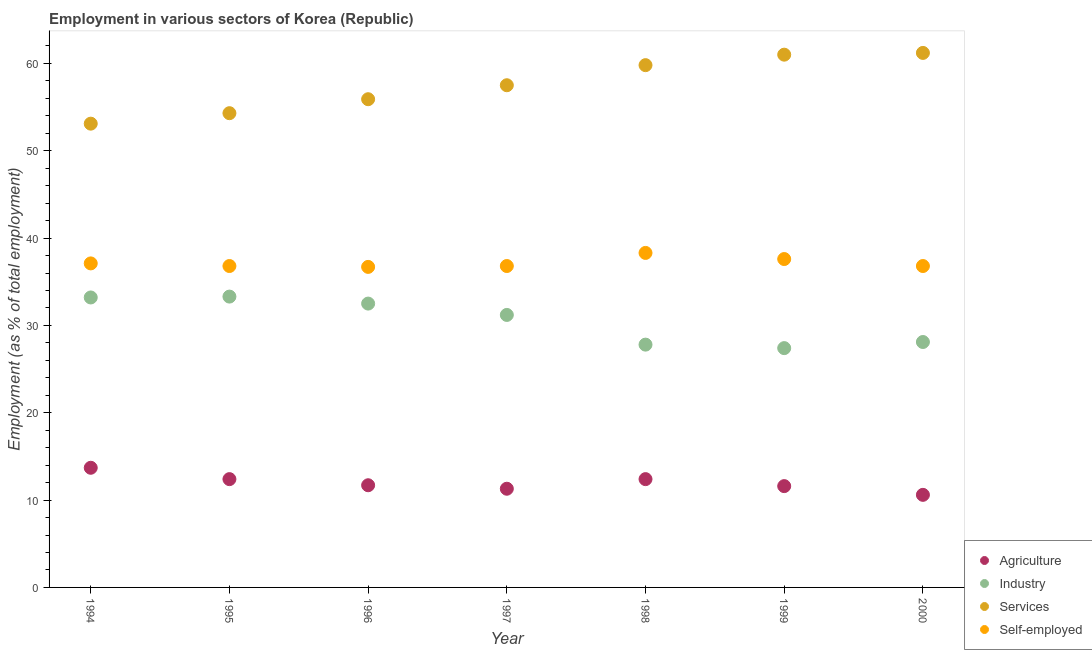How many different coloured dotlines are there?
Keep it short and to the point. 4. What is the percentage of workers in services in 1997?
Your answer should be compact. 57.5. Across all years, what is the maximum percentage of workers in services?
Your answer should be compact. 61.2. Across all years, what is the minimum percentage of workers in services?
Provide a short and direct response. 53.1. In which year was the percentage of self employed workers minimum?
Your answer should be compact. 1996. What is the total percentage of workers in agriculture in the graph?
Your response must be concise. 83.7. What is the difference between the percentage of self employed workers in 1994 and that in 1997?
Keep it short and to the point. 0.3. What is the difference between the percentage of workers in agriculture in 1998 and the percentage of workers in services in 1995?
Offer a very short reply. -41.9. What is the average percentage of workers in industry per year?
Offer a very short reply. 30.5. In the year 1996, what is the difference between the percentage of self employed workers and percentage of workers in services?
Your answer should be very brief. -19.2. What is the ratio of the percentage of self employed workers in 1999 to that in 2000?
Keep it short and to the point. 1.02. What is the difference between the highest and the second highest percentage of self employed workers?
Your answer should be very brief. 0.7. What is the difference between the highest and the lowest percentage of workers in agriculture?
Keep it short and to the point. 3.1. In how many years, is the percentage of self employed workers greater than the average percentage of self employed workers taken over all years?
Your answer should be compact. 2. Is the sum of the percentage of self employed workers in 1994 and 1997 greater than the maximum percentage of workers in industry across all years?
Your answer should be very brief. Yes. Does the percentage of workers in services monotonically increase over the years?
Provide a succinct answer. Yes. Is the percentage of workers in services strictly less than the percentage of workers in industry over the years?
Offer a very short reply. No. How many years are there in the graph?
Make the answer very short. 7. What is the difference between two consecutive major ticks on the Y-axis?
Offer a very short reply. 10. Are the values on the major ticks of Y-axis written in scientific E-notation?
Your answer should be very brief. No. Does the graph contain any zero values?
Make the answer very short. No. What is the title of the graph?
Provide a short and direct response. Employment in various sectors of Korea (Republic). What is the label or title of the X-axis?
Your answer should be very brief. Year. What is the label or title of the Y-axis?
Offer a very short reply. Employment (as % of total employment). What is the Employment (as % of total employment) in Agriculture in 1994?
Ensure brevity in your answer.  13.7. What is the Employment (as % of total employment) in Industry in 1994?
Your answer should be very brief. 33.2. What is the Employment (as % of total employment) of Services in 1994?
Make the answer very short. 53.1. What is the Employment (as % of total employment) in Self-employed in 1994?
Provide a short and direct response. 37.1. What is the Employment (as % of total employment) of Agriculture in 1995?
Your response must be concise. 12.4. What is the Employment (as % of total employment) in Industry in 1995?
Your answer should be compact. 33.3. What is the Employment (as % of total employment) of Services in 1995?
Your answer should be compact. 54.3. What is the Employment (as % of total employment) of Self-employed in 1995?
Provide a succinct answer. 36.8. What is the Employment (as % of total employment) of Agriculture in 1996?
Give a very brief answer. 11.7. What is the Employment (as % of total employment) in Industry in 1996?
Your answer should be compact. 32.5. What is the Employment (as % of total employment) of Services in 1996?
Make the answer very short. 55.9. What is the Employment (as % of total employment) in Self-employed in 1996?
Make the answer very short. 36.7. What is the Employment (as % of total employment) of Agriculture in 1997?
Your answer should be very brief. 11.3. What is the Employment (as % of total employment) in Industry in 1997?
Your response must be concise. 31.2. What is the Employment (as % of total employment) of Services in 1997?
Ensure brevity in your answer.  57.5. What is the Employment (as % of total employment) of Self-employed in 1997?
Give a very brief answer. 36.8. What is the Employment (as % of total employment) of Agriculture in 1998?
Your answer should be compact. 12.4. What is the Employment (as % of total employment) of Industry in 1998?
Your answer should be compact. 27.8. What is the Employment (as % of total employment) of Services in 1998?
Make the answer very short. 59.8. What is the Employment (as % of total employment) of Self-employed in 1998?
Provide a succinct answer. 38.3. What is the Employment (as % of total employment) of Agriculture in 1999?
Ensure brevity in your answer.  11.6. What is the Employment (as % of total employment) of Industry in 1999?
Your answer should be very brief. 27.4. What is the Employment (as % of total employment) of Self-employed in 1999?
Make the answer very short. 37.6. What is the Employment (as % of total employment) of Agriculture in 2000?
Give a very brief answer. 10.6. What is the Employment (as % of total employment) of Industry in 2000?
Your answer should be very brief. 28.1. What is the Employment (as % of total employment) in Services in 2000?
Provide a succinct answer. 61.2. What is the Employment (as % of total employment) in Self-employed in 2000?
Give a very brief answer. 36.8. Across all years, what is the maximum Employment (as % of total employment) of Agriculture?
Offer a very short reply. 13.7. Across all years, what is the maximum Employment (as % of total employment) in Industry?
Give a very brief answer. 33.3. Across all years, what is the maximum Employment (as % of total employment) of Services?
Offer a terse response. 61.2. Across all years, what is the maximum Employment (as % of total employment) of Self-employed?
Make the answer very short. 38.3. Across all years, what is the minimum Employment (as % of total employment) in Agriculture?
Your response must be concise. 10.6. Across all years, what is the minimum Employment (as % of total employment) in Industry?
Provide a succinct answer. 27.4. Across all years, what is the minimum Employment (as % of total employment) in Services?
Provide a succinct answer. 53.1. Across all years, what is the minimum Employment (as % of total employment) in Self-employed?
Offer a very short reply. 36.7. What is the total Employment (as % of total employment) in Agriculture in the graph?
Your response must be concise. 83.7. What is the total Employment (as % of total employment) in Industry in the graph?
Provide a short and direct response. 213.5. What is the total Employment (as % of total employment) in Services in the graph?
Offer a terse response. 402.8. What is the total Employment (as % of total employment) of Self-employed in the graph?
Your response must be concise. 260.1. What is the difference between the Employment (as % of total employment) in Self-employed in 1994 and that in 1995?
Your response must be concise. 0.3. What is the difference between the Employment (as % of total employment) of Agriculture in 1994 and that in 1996?
Your answer should be compact. 2. What is the difference between the Employment (as % of total employment) in Services in 1994 and that in 1996?
Offer a very short reply. -2.8. What is the difference between the Employment (as % of total employment) in Self-employed in 1994 and that in 1996?
Keep it short and to the point. 0.4. What is the difference between the Employment (as % of total employment) of Services in 1994 and that in 1997?
Your answer should be very brief. -4.4. What is the difference between the Employment (as % of total employment) of Self-employed in 1994 and that in 1997?
Your answer should be very brief. 0.3. What is the difference between the Employment (as % of total employment) in Agriculture in 1994 and that in 1998?
Give a very brief answer. 1.3. What is the difference between the Employment (as % of total employment) of Industry in 1994 and that in 1998?
Keep it short and to the point. 5.4. What is the difference between the Employment (as % of total employment) in Self-employed in 1994 and that in 1998?
Give a very brief answer. -1.2. What is the difference between the Employment (as % of total employment) in Agriculture in 1994 and that in 1999?
Ensure brevity in your answer.  2.1. What is the difference between the Employment (as % of total employment) in Agriculture in 1994 and that in 2000?
Offer a terse response. 3.1. What is the difference between the Employment (as % of total employment) of Self-employed in 1994 and that in 2000?
Ensure brevity in your answer.  0.3. What is the difference between the Employment (as % of total employment) in Agriculture in 1995 and that in 1996?
Ensure brevity in your answer.  0.7. What is the difference between the Employment (as % of total employment) of Industry in 1995 and that in 1996?
Your response must be concise. 0.8. What is the difference between the Employment (as % of total employment) in Self-employed in 1995 and that in 1996?
Ensure brevity in your answer.  0.1. What is the difference between the Employment (as % of total employment) of Industry in 1995 and that in 1997?
Give a very brief answer. 2.1. What is the difference between the Employment (as % of total employment) in Self-employed in 1995 and that in 1997?
Make the answer very short. 0. What is the difference between the Employment (as % of total employment) of Industry in 1995 and that in 1998?
Your response must be concise. 5.5. What is the difference between the Employment (as % of total employment) of Services in 1995 and that in 1999?
Offer a very short reply. -6.7. What is the difference between the Employment (as % of total employment) of Self-employed in 1995 and that in 2000?
Ensure brevity in your answer.  0. What is the difference between the Employment (as % of total employment) of Agriculture in 1996 and that in 1997?
Ensure brevity in your answer.  0.4. What is the difference between the Employment (as % of total employment) of Self-employed in 1996 and that in 1997?
Your response must be concise. -0.1. What is the difference between the Employment (as % of total employment) of Agriculture in 1996 and that in 1998?
Your answer should be very brief. -0.7. What is the difference between the Employment (as % of total employment) in Services in 1996 and that in 1998?
Offer a terse response. -3.9. What is the difference between the Employment (as % of total employment) in Agriculture in 1996 and that in 1999?
Your answer should be very brief. 0.1. What is the difference between the Employment (as % of total employment) of Services in 1996 and that in 1999?
Your answer should be compact. -5.1. What is the difference between the Employment (as % of total employment) of Self-employed in 1996 and that in 1999?
Keep it short and to the point. -0.9. What is the difference between the Employment (as % of total employment) of Services in 1996 and that in 2000?
Offer a very short reply. -5.3. What is the difference between the Employment (as % of total employment) of Agriculture in 1997 and that in 1998?
Make the answer very short. -1.1. What is the difference between the Employment (as % of total employment) in Industry in 1997 and that in 1998?
Your answer should be very brief. 3.4. What is the difference between the Employment (as % of total employment) of Self-employed in 1997 and that in 1998?
Your response must be concise. -1.5. What is the difference between the Employment (as % of total employment) of Agriculture in 1997 and that in 1999?
Your answer should be compact. -0.3. What is the difference between the Employment (as % of total employment) in Industry in 1997 and that in 1999?
Offer a very short reply. 3.8. What is the difference between the Employment (as % of total employment) of Self-employed in 1997 and that in 1999?
Offer a terse response. -0.8. What is the difference between the Employment (as % of total employment) in Services in 1997 and that in 2000?
Offer a terse response. -3.7. What is the difference between the Employment (as % of total employment) of Self-employed in 1997 and that in 2000?
Provide a short and direct response. 0. What is the difference between the Employment (as % of total employment) in Agriculture in 1998 and that in 1999?
Keep it short and to the point. 0.8. What is the difference between the Employment (as % of total employment) of Industry in 1998 and that in 1999?
Keep it short and to the point. 0.4. What is the difference between the Employment (as % of total employment) of Self-employed in 1998 and that in 1999?
Your response must be concise. 0.7. What is the difference between the Employment (as % of total employment) of Agriculture in 1998 and that in 2000?
Offer a terse response. 1.8. What is the difference between the Employment (as % of total employment) in Industry in 1998 and that in 2000?
Ensure brevity in your answer.  -0.3. What is the difference between the Employment (as % of total employment) in Services in 1998 and that in 2000?
Your response must be concise. -1.4. What is the difference between the Employment (as % of total employment) of Self-employed in 1998 and that in 2000?
Provide a short and direct response. 1.5. What is the difference between the Employment (as % of total employment) in Agriculture in 1999 and that in 2000?
Provide a short and direct response. 1. What is the difference between the Employment (as % of total employment) in Industry in 1999 and that in 2000?
Your answer should be very brief. -0.7. What is the difference between the Employment (as % of total employment) in Services in 1999 and that in 2000?
Make the answer very short. -0.2. What is the difference between the Employment (as % of total employment) in Self-employed in 1999 and that in 2000?
Provide a succinct answer. 0.8. What is the difference between the Employment (as % of total employment) of Agriculture in 1994 and the Employment (as % of total employment) of Industry in 1995?
Your response must be concise. -19.6. What is the difference between the Employment (as % of total employment) of Agriculture in 1994 and the Employment (as % of total employment) of Services in 1995?
Give a very brief answer. -40.6. What is the difference between the Employment (as % of total employment) in Agriculture in 1994 and the Employment (as % of total employment) in Self-employed in 1995?
Offer a terse response. -23.1. What is the difference between the Employment (as % of total employment) in Industry in 1994 and the Employment (as % of total employment) in Services in 1995?
Make the answer very short. -21.1. What is the difference between the Employment (as % of total employment) of Services in 1994 and the Employment (as % of total employment) of Self-employed in 1995?
Provide a short and direct response. 16.3. What is the difference between the Employment (as % of total employment) in Agriculture in 1994 and the Employment (as % of total employment) in Industry in 1996?
Give a very brief answer. -18.8. What is the difference between the Employment (as % of total employment) in Agriculture in 1994 and the Employment (as % of total employment) in Services in 1996?
Keep it short and to the point. -42.2. What is the difference between the Employment (as % of total employment) in Industry in 1994 and the Employment (as % of total employment) in Services in 1996?
Your answer should be very brief. -22.7. What is the difference between the Employment (as % of total employment) in Agriculture in 1994 and the Employment (as % of total employment) in Industry in 1997?
Your response must be concise. -17.5. What is the difference between the Employment (as % of total employment) in Agriculture in 1994 and the Employment (as % of total employment) in Services in 1997?
Offer a very short reply. -43.8. What is the difference between the Employment (as % of total employment) of Agriculture in 1994 and the Employment (as % of total employment) of Self-employed in 1997?
Provide a short and direct response. -23.1. What is the difference between the Employment (as % of total employment) in Industry in 1994 and the Employment (as % of total employment) in Services in 1997?
Ensure brevity in your answer.  -24.3. What is the difference between the Employment (as % of total employment) in Industry in 1994 and the Employment (as % of total employment) in Self-employed in 1997?
Your answer should be compact. -3.6. What is the difference between the Employment (as % of total employment) in Services in 1994 and the Employment (as % of total employment) in Self-employed in 1997?
Offer a very short reply. 16.3. What is the difference between the Employment (as % of total employment) in Agriculture in 1994 and the Employment (as % of total employment) in Industry in 1998?
Keep it short and to the point. -14.1. What is the difference between the Employment (as % of total employment) in Agriculture in 1994 and the Employment (as % of total employment) in Services in 1998?
Ensure brevity in your answer.  -46.1. What is the difference between the Employment (as % of total employment) of Agriculture in 1994 and the Employment (as % of total employment) of Self-employed in 1998?
Your answer should be very brief. -24.6. What is the difference between the Employment (as % of total employment) in Industry in 1994 and the Employment (as % of total employment) in Services in 1998?
Provide a short and direct response. -26.6. What is the difference between the Employment (as % of total employment) of Agriculture in 1994 and the Employment (as % of total employment) of Industry in 1999?
Give a very brief answer. -13.7. What is the difference between the Employment (as % of total employment) of Agriculture in 1994 and the Employment (as % of total employment) of Services in 1999?
Provide a short and direct response. -47.3. What is the difference between the Employment (as % of total employment) in Agriculture in 1994 and the Employment (as % of total employment) in Self-employed in 1999?
Your answer should be compact. -23.9. What is the difference between the Employment (as % of total employment) of Industry in 1994 and the Employment (as % of total employment) of Services in 1999?
Give a very brief answer. -27.8. What is the difference between the Employment (as % of total employment) of Services in 1994 and the Employment (as % of total employment) of Self-employed in 1999?
Provide a short and direct response. 15.5. What is the difference between the Employment (as % of total employment) of Agriculture in 1994 and the Employment (as % of total employment) of Industry in 2000?
Your answer should be very brief. -14.4. What is the difference between the Employment (as % of total employment) in Agriculture in 1994 and the Employment (as % of total employment) in Services in 2000?
Keep it short and to the point. -47.5. What is the difference between the Employment (as % of total employment) in Agriculture in 1994 and the Employment (as % of total employment) in Self-employed in 2000?
Keep it short and to the point. -23.1. What is the difference between the Employment (as % of total employment) of Services in 1994 and the Employment (as % of total employment) of Self-employed in 2000?
Your response must be concise. 16.3. What is the difference between the Employment (as % of total employment) in Agriculture in 1995 and the Employment (as % of total employment) in Industry in 1996?
Ensure brevity in your answer.  -20.1. What is the difference between the Employment (as % of total employment) in Agriculture in 1995 and the Employment (as % of total employment) in Services in 1996?
Your response must be concise. -43.5. What is the difference between the Employment (as % of total employment) of Agriculture in 1995 and the Employment (as % of total employment) of Self-employed in 1996?
Provide a succinct answer. -24.3. What is the difference between the Employment (as % of total employment) of Industry in 1995 and the Employment (as % of total employment) of Services in 1996?
Provide a succinct answer. -22.6. What is the difference between the Employment (as % of total employment) of Industry in 1995 and the Employment (as % of total employment) of Self-employed in 1996?
Keep it short and to the point. -3.4. What is the difference between the Employment (as % of total employment) in Services in 1995 and the Employment (as % of total employment) in Self-employed in 1996?
Your response must be concise. 17.6. What is the difference between the Employment (as % of total employment) in Agriculture in 1995 and the Employment (as % of total employment) in Industry in 1997?
Provide a short and direct response. -18.8. What is the difference between the Employment (as % of total employment) in Agriculture in 1995 and the Employment (as % of total employment) in Services in 1997?
Your answer should be very brief. -45.1. What is the difference between the Employment (as % of total employment) in Agriculture in 1995 and the Employment (as % of total employment) in Self-employed in 1997?
Keep it short and to the point. -24.4. What is the difference between the Employment (as % of total employment) in Industry in 1995 and the Employment (as % of total employment) in Services in 1997?
Provide a short and direct response. -24.2. What is the difference between the Employment (as % of total employment) in Industry in 1995 and the Employment (as % of total employment) in Self-employed in 1997?
Keep it short and to the point. -3.5. What is the difference between the Employment (as % of total employment) of Services in 1995 and the Employment (as % of total employment) of Self-employed in 1997?
Your answer should be very brief. 17.5. What is the difference between the Employment (as % of total employment) in Agriculture in 1995 and the Employment (as % of total employment) in Industry in 1998?
Your response must be concise. -15.4. What is the difference between the Employment (as % of total employment) in Agriculture in 1995 and the Employment (as % of total employment) in Services in 1998?
Offer a terse response. -47.4. What is the difference between the Employment (as % of total employment) in Agriculture in 1995 and the Employment (as % of total employment) in Self-employed in 1998?
Keep it short and to the point. -25.9. What is the difference between the Employment (as % of total employment) of Industry in 1995 and the Employment (as % of total employment) of Services in 1998?
Provide a short and direct response. -26.5. What is the difference between the Employment (as % of total employment) of Industry in 1995 and the Employment (as % of total employment) of Self-employed in 1998?
Ensure brevity in your answer.  -5. What is the difference between the Employment (as % of total employment) of Services in 1995 and the Employment (as % of total employment) of Self-employed in 1998?
Your response must be concise. 16. What is the difference between the Employment (as % of total employment) in Agriculture in 1995 and the Employment (as % of total employment) in Industry in 1999?
Give a very brief answer. -15. What is the difference between the Employment (as % of total employment) of Agriculture in 1995 and the Employment (as % of total employment) of Services in 1999?
Make the answer very short. -48.6. What is the difference between the Employment (as % of total employment) in Agriculture in 1995 and the Employment (as % of total employment) in Self-employed in 1999?
Ensure brevity in your answer.  -25.2. What is the difference between the Employment (as % of total employment) of Industry in 1995 and the Employment (as % of total employment) of Services in 1999?
Make the answer very short. -27.7. What is the difference between the Employment (as % of total employment) in Services in 1995 and the Employment (as % of total employment) in Self-employed in 1999?
Provide a succinct answer. 16.7. What is the difference between the Employment (as % of total employment) in Agriculture in 1995 and the Employment (as % of total employment) in Industry in 2000?
Provide a short and direct response. -15.7. What is the difference between the Employment (as % of total employment) in Agriculture in 1995 and the Employment (as % of total employment) in Services in 2000?
Your answer should be very brief. -48.8. What is the difference between the Employment (as % of total employment) in Agriculture in 1995 and the Employment (as % of total employment) in Self-employed in 2000?
Your answer should be compact. -24.4. What is the difference between the Employment (as % of total employment) of Industry in 1995 and the Employment (as % of total employment) of Services in 2000?
Give a very brief answer. -27.9. What is the difference between the Employment (as % of total employment) of Industry in 1995 and the Employment (as % of total employment) of Self-employed in 2000?
Your answer should be very brief. -3.5. What is the difference between the Employment (as % of total employment) in Services in 1995 and the Employment (as % of total employment) in Self-employed in 2000?
Keep it short and to the point. 17.5. What is the difference between the Employment (as % of total employment) in Agriculture in 1996 and the Employment (as % of total employment) in Industry in 1997?
Make the answer very short. -19.5. What is the difference between the Employment (as % of total employment) of Agriculture in 1996 and the Employment (as % of total employment) of Services in 1997?
Keep it short and to the point. -45.8. What is the difference between the Employment (as % of total employment) in Agriculture in 1996 and the Employment (as % of total employment) in Self-employed in 1997?
Offer a very short reply. -25.1. What is the difference between the Employment (as % of total employment) of Industry in 1996 and the Employment (as % of total employment) of Services in 1997?
Your answer should be very brief. -25. What is the difference between the Employment (as % of total employment) in Services in 1996 and the Employment (as % of total employment) in Self-employed in 1997?
Ensure brevity in your answer.  19.1. What is the difference between the Employment (as % of total employment) of Agriculture in 1996 and the Employment (as % of total employment) of Industry in 1998?
Ensure brevity in your answer.  -16.1. What is the difference between the Employment (as % of total employment) in Agriculture in 1996 and the Employment (as % of total employment) in Services in 1998?
Make the answer very short. -48.1. What is the difference between the Employment (as % of total employment) of Agriculture in 1996 and the Employment (as % of total employment) of Self-employed in 1998?
Provide a short and direct response. -26.6. What is the difference between the Employment (as % of total employment) of Industry in 1996 and the Employment (as % of total employment) of Services in 1998?
Keep it short and to the point. -27.3. What is the difference between the Employment (as % of total employment) of Services in 1996 and the Employment (as % of total employment) of Self-employed in 1998?
Make the answer very short. 17.6. What is the difference between the Employment (as % of total employment) in Agriculture in 1996 and the Employment (as % of total employment) in Industry in 1999?
Keep it short and to the point. -15.7. What is the difference between the Employment (as % of total employment) of Agriculture in 1996 and the Employment (as % of total employment) of Services in 1999?
Ensure brevity in your answer.  -49.3. What is the difference between the Employment (as % of total employment) of Agriculture in 1996 and the Employment (as % of total employment) of Self-employed in 1999?
Ensure brevity in your answer.  -25.9. What is the difference between the Employment (as % of total employment) of Industry in 1996 and the Employment (as % of total employment) of Services in 1999?
Your answer should be very brief. -28.5. What is the difference between the Employment (as % of total employment) of Industry in 1996 and the Employment (as % of total employment) of Self-employed in 1999?
Provide a succinct answer. -5.1. What is the difference between the Employment (as % of total employment) of Services in 1996 and the Employment (as % of total employment) of Self-employed in 1999?
Give a very brief answer. 18.3. What is the difference between the Employment (as % of total employment) in Agriculture in 1996 and the Employment (as % of total employment) in Industry in 2000?
Provide a short and direct response. -16.4. What is the difference between the Employment (as % of total employment) of Agriculture in 1996 and the Employment (as % of total employment) of Services in 2000?
Give a very brief answer. -49.5. What is the difference between the Employment (as % of total employment) of Agriculture in 1996 and the Employment (as % of total employment) of Self-employed in 2000?
Provide a succinct answer. -25.1. What is the difference between the Employment (as % of total employment) of Industry in 1996 and the Employment (as % of total employment) of Services in 2000?
Provide a succinct answer. -28.7. What is the difference between the Employment (as % of total employment) of Industry in 1996 and the Employment (as % of total employment) of Self-employed in 2000?
Give a very brief answer. -4.3. What is the difference between the Employment (as % of total employment) in Agriculture in 1997 and the Employment (as % of total employment) in Industry in 1998?
Make the answer very short. -16.5. What is the difference between the Employment (as % of total employment) of Agriculture in 1997 and the Employment (as % of total employment) of Services in 1998?
Ensure brevity in your answer.  -48.5. What is the difference between the Employment (as % of total employment) in Industry in 1997 and the Employment (as % of total employment) in Services in 1998?
Make the answer very short. -28.6. What is the difference between the Employment (as % of total employment) of Industry in 1997 and the Employment (as % of total employment) of Self-employed in 1998?
Keep it short and to the point. -7.1. What is the difference between the Employment (as % of total employment) of Services in 1997 and the Employment (as % of total employment) of Self-employed in 1998?
Offer a very short reply. 19.2. What is the difference between the Employment (as % of total employment) in Agriculture in 1997 and the Employment (as % of total employment) in Industry in 1999?
Offer a very short reply. -16.1. What is the difference between the Employment (as % of total employment) in Agriculture in 1997 and the Employment (as % of total employment) in Services in 1999?
Give a very brief answer. -49.7. What is the difference between the Employment (as % of total employment) of Agriculture in 1997 and the Employment (as % of total employment) of Self-employed in 1999?
Your response must be concise. -26.3. What is the difference between the Employment (as % of total employment) of Industry in 1997 and the Employment (as % of total employment) of Services in 1999?
Give a very brief answer. -29.8. What is the difference between the Employment (as % of total employment) in Services in 1997 and the Employment (as % of total employment) in Self-employed in 1999?
Offer a terse response. 19.9. What is the difference between the Employment (as % of total employment) in Agriculture in 1997 and the Employment (as % of total employment) in Industry in 2000?
Ensure brevity in your answer.  -16.8. What is the difference between the Employment (as % of total employment) of Agriculture in 1997 and the Employment (as % of total employment) of Services in 2000?
Provide a succinct answer. -49.9. What is the difference between the Employment (as % of total employment) in Agriculture in 1997 and the Employment (as % of total employment) in Self-employed in 2000?
Your answer should be very brief. -25.5. What is the difference between the Employment (as % of total employment) in Services in 1997 and the Employment (as % of total employment) in Self-employed in 2000?
Provide a succinct answer. 20.7. What is the difference between the Employment (as % of total employment) of Agriculture in 1998 and the Employment (as % of total employment) of Industry in 1999?
Keep it short and to the point. -15. What is the difference between the Employment (as % of total employment) of Agriculture in 1998 and the Employment (as % of total employment) of Services in 1999?
Provide a succinct answer. -48.6. What is the difference between the Employment (as % of total employment) of Agriculture in 1998 and the Employment (as % of total employment) of Self-employed in 1999?
Make the answer very short. -25.2. What is the difference between the Employment (as % of total employment) in Industry in 1998 and the Employment (as % of total employment) in Services in 1999?
Your answer should be very brief. -33.2. What is the difference between the Employment (as % of total employment) in Services in 1998 and the Employment (as % of total employment) in Self-employed in 1999?
Your answer should be compact. 22.2. What is the difference between the Employment (as % of total employment) in Agriculture in 1998 and the Employment (as % of total employment) in Industry in 2000?
Give a very brief answer. -15.7. What is the difference between the Employment (as % of total employment) of Agriculture in 1998 and the Employment (as % of total employment) of Services in 2000?
Your answer should be compact. -48.8. What is the difference between the Employment (as % of total employment) of Agriculture in 1998 and the Employment (as % of total employment) of Self-employed in 2000?
Offer a terse response. -24.4. What is the difference between the Employment (as % of total employment) in Industry in 1998 and the Employment (as % of total employment) in Services in 2000?
Keep it short and to the point. -33.4. What is the difference between the Employment (as % of total employment) of Services in 1998 and the Employment (as % of total employment) of Self-employed in 2000?
Give a very brief answer. 23. What is the difference between the Employment (as % of total employment) of Agriculture in 1999 and the Employment (as % of total employment) of Industry in 2000?
Make the answer very short. -16.5. What is the difference between the Employment (as % of total employment) in Agriculture in 1999 and the Employment (as % of total employment) in Services in 2000?
Give a very brief answer. -49.6. What is the difference between the Employment (as % of total employment) in Agriculture in 1999 and the Employment (as % of total employment) in Self-employed in 2000?
Provide a short and direct response. -25.2. What is the difference between the Employment (as % of total employment) of Industry in 1999 and the Employment (as % of total employment) of Services in 2000?
Your answer should be compact. -33.8. What is the difference between the Employment (as % of total employment) in Services in 1999 and the Employment (as % of total employment) in Self-employed in 2000?
Your answer should be very brief. 24.2. What is the average Employment (as % of total employment) of Agriculture per year?
Keep it short and to the point. 11.96. What is the average Employment (as % of total employment) in Industry per year?
Your answer should be very brief. 30.5. What is the average Employment (as % of total employment) of Services per year?
Provide a succinct answer. 57.54. What is the average Employment (as % of total employment) in Self-employed per year?
Your response must be concise. 37.16. In the year 1994, what is the difference between the Employment (as % of total employment) of Agriculture and Employment (as % of total employment) of Industry?
Provide a succinct answer. -19.5. In the year 1994, what is the difference between the Employment (as % of total employment) of Agriculture and Employment (as % of total employment) of Services?
Provide a succinct answer. -39.4. In the year 1994, what is the difference between the Employment (as % of total employment) of Agriculture and Employment (as % of total employment) of Self-employed?
Make the answer very short. -23.4. In the year 1994, what is the difference between the Employment (as % of total employment) in Industry and Employment (as % of total employment) in Services?
Your response must be concise. -19.9. In the year 1995, what is the difference between the Employment (as % of total employment) of Agriculture and Employment (as % of total employment) of Industry?
Your answer should be compact. -20.9. In the year 1995, what is the difference between the Employment (as % of total employment) of Agriculture and Employment (as % of total employment) of Services?
Your answer should be very brief. -41.9. In the year 1995, what is the difference between the Employment (as % of total employment) in Agriculture and Employment (as % of total employment) in Self-employed?
Provide a succinct answer. -24.4. In the year 1995, what is the difference between the Employment (as % of total employment) in Industry and Employment (as % of total employment) in Services?
Provide a succinct answer. -21. In the year 1996, what is the difference between the Employment (as % of total employment) of Agriculture and Employment (as % of total employment) of Industry?
Ensure brevity in your answer.  -20.8. In the year 1996, what is the difference between the Employment (as % of total employment) in Agriculture and Employment (as % of total employment) in Services?
Your response must be concise. -44.2. In the year 1996, what is the difference between the Employment (as % of total employment) in Agriculture and Employment (as % of total employment) in Self-employed?
Your answer should be compact. -25. In the year 1996, what is the difference between the Employment (as % of total employment) of Industry and Employment (as % of total employment) of Services?
Offer a very short reply. -23.4. In the year 1997, what is the difference between the Employment (as % of total employment) of Agriculture and Employment (as % of total employment) of Industry?
Make the answer very short. -19.9. In the year 1997, what is the difference between the Employment (as % of total employment) in Agriculture and Employment (as % of total employment) in Services?
Provide a succinct answer. -46.2. In the year 1997, what is the difference between the Employment (as % of total employment) of Agriculture and Employment (as % of total employment) of Self-employed?
Provide a succinct answer. -25.5. In the year 1997, what is the difference between the Employment (as % of total employment) of Industry and Employment (as % of total employment) of Services?
Your answer should be compact. -26.3. In the year 1997, what is the difference between the Employment (as % of total employment) in Industry and Employment (as % of total employment) in Self-employed?
Offer a very short reply. -5.6. In the year 1997, what is the difference between the Employment (as % of total employment) of Services and Employment (as % of total employment) of Self-employed?
Give a very brief answer. 20.7. In the year 1998, what is the difference between the Employment (as % of total employment) in Agriculture and Employment (as % of total employment) in Industry?
Your answer should be very brief. -15.4. In the year 1998, what is the difference between the Employment (as % of total employment) in Agriculture and Employment (as % of total employment) in Services?
Keep it short and to the point. -47.4. In the year 1998, what is the difference between the Employment (as % of total employment) of Agriculture and Employment (as % of total employment) of Self-employed?
Offer a very short reply. -25.9. In the year 1998, what is the difference between the Employment (as % of total employment) of Industry and Employment (as % of total employment) of Services?
Offer a very short reply. -32. In the year 1998, what is the difference between the Employment (as % of total employment) of Services and Employment (as % of total employment) of Self-employed?
Keep it short and to the point. 21.5. In the year 1999, what is the difference between the Employment (as % of total employment) of Agriculture and Employment (as % of total employment) of Industry?
Offer a terse response. -15.8. In the year 1999, what is the difference between the Employment (as % of total employment) in Agriculture and Employment (as % of total employment) in Services?
Provide a short and direct response. -49.4. In the year 1999, what is the difference between the Employment (as % of total employment) of Agriculture and Employment (as % of total employment) of Self-employed?
Provide a succinct answer. -26. In the year 1999, what is the difference between the Employment (as % of total employment) in Industry and Employment (as % of total employment) in Services?
Make the answer very short. -33.6. In the year 1999, what is the difference between the Employment (as % of total employment) of Services and Employment (as % of total employment) of Self-employed?
Your answer should be very brief. 23.4. In the year 2000, what is the difference between the Employment (as % of total employment) of Agriculture and Employment (as % of total employment) of Industry?
Your answer should be very brief. -17.5. In the year 2000, what is the difference between the Employment (as % of total employment) of Agriculture and Employment (as % of total employment) of Services?
Offer a very short reply. -50.6. In the year 2000, what is the difference between the Employment (as % of total employment) in Agriculture and Employment (as % of total employment) in Self-employed?
Offer a very short reply. -26.2. In the year 2000, what is the difference between the Employment (as % of total employment) of Industry and Employment (as % of total employment) of Services?
Keep it short and to the point. -33.1. In the year 2000, what is the difference between the Employment (as % of total employment) in Industry and Employment (as % of total employment) in Self-employed?
Provide a short and direct response. -8.7. In the year 2000, what is the difference between the Employment (as % of total employment) in Services and Employment (as % of total employment) in Self-employed?
Offer a terse response. 24.4. What is the ratio of the Employment (as % of total employment) in Agriculture in 1994 to that in 1995?
Give a very brief answer. 1.1. What is the ratio of the Employment (as % of total employment) of Services in 1994 to that in 1995?
Provide a succinct answer. 0.98. What is the ratio of the Employment (as % of total employment) in Self-employed in 1994 to that in 1995?
Your response must be concise. 1.01. What is the ratio of the Employment (as % of total employment) in Agriculture in 1994 to that in 1996?
Provide a succinct answer. 1.17. What is the ratio of the Employment (as % of total employment) of Industry in 1994 to that in 1996?
Offer a very short reply. 1.02. What is the ratio of the Employment (as % of total employment) of Services in 1994 to that in 1996?
Make the answer very short. 0.95. What is the ratio of the Employment (as % of total employment) in Self-employed in 1994 to that in 1996?
Provide a short and direct response. 1.01. What is the ratio of the Employment (as % of total employment) of Agriculture in 1994 to that in 1997?
Provide a short and direct response. 1.21. What is the ratio of the Employment (as % of total employment) in Industry in 1994 to that in 1997?
Your response must be concise. 1.06. What is the ratio of the Employment (as % of total employment) in Services in 1994 to that in 1997?
Give a very brief answer. 0.92. What is the ratio of the Employment (as % of total employment) of Self-employed in 1994 to that in 1997?
Keep it short and to the point. 1.01. What is the ratio of the Employment (as % of total employment) in Agriculture in 1994 to that in 1998?
Your answer should be very brief. 1.1. What is the ratio of the Employment (as % of total employment) of Industry in 1994 to that in 1998?
Your response must be concise. 1.19. What is the ratio of the Employment (as % of total employment) of Services in 1994 to that in 1998?
Provide a succinct answer. 0.89. What is the ratio of the Employment (as % of total employment) of Self-employed in 1994 to that in 1998?
Your response must be concise. 0.97. What is the ratio of the Employment (as % of total employment) in Agriculture in 1994 to that in 1999?
Keep it short and to the point. 1.18. What is the ratio of the Employment (as % of total employment) of Industry in 1994 to that in 1999?
Offer a very short reply. 1.21. What is the ratio of the Employment (as % of total employment) in Services in 1994 to that in 1999?
Provide a succinct answer. 0.87. What is the ratio of the Employment (as % of total employment) in Self-employed in 1994 to that in 1999?
Offer a terse response. 0.99. What is the ratio of the Employment (as % of total employment) of Agriculture in 1994 to that in 2000?
Offer a very short reply. 1.29. What is the ratio of the Employment (as % of total employment) of Industry in 1994 to that in 2000?
Ensure brevity in your answer.  1.18. What is the ratio of the Employment (as % of total employment) of Services in 1994 to that in 2000?
Give a very brief answer. 0.87. What is the ratio of the Employment (as % of total employment) in Self-employed in 1994 to that in 2000?
Provide a short and direct response. 1.01. What is the ratio of the Employment (as % of total employment) in Agriculture in 1995 to that in 1996?
Provide a short and direct response. 1.06. What is the ratio of the Employment (as % of total employment) in Industry in 1995 to that in 1996?
Offer a terse response. 1.02. What is the ratio of the Employment (as % of total employment) in Services in 1995 to that in 1996?
Your answer should be compact. 0.97. What is the ratio of the Employment (as % of total employment) of Self-employed in 1995 to that in 1996?
Provide a short and direct response. 1. What is the ratio of the Employment (as % of total employment) of Agriculture in 1995 to that in 1997?
Provide a short and direct response. 1.1. What is the ratio of the Employment (as % of total employment) of Industry in 1995 to that in 1997?
Ensure brevity in your answer.  1.07. What is the ratio of the Employment (as % of total employment) of Services in 1995 to that in 1997?
Provide a succinct answer. 0.94. What is the ratio of the Employment (as % of total employment) of Agriculture in 1995 to that in 1998?
Your answer should be very brief. 1. What is the ratio of the Employment (as % of total employment) of Industry in 1995 to that in 1998?
Your response must be concise. 1.2. What is the ratio of the Employment (as % of total employment) in Services in 1995 to that in 1998?
Give a very brief answer. 0.91. What is the ratio of the Employment (as % of total employment) in Self-employed in 1995 to that in 1998?
Your response must be concise. 0.96. What is the ratio of the Employment (as % of total employment) in Agriculture in 1995 to that in 1999?
Make the answer very short. 1.07. What is the ratio of the Employment (as % of total employment) in Industry in 1995 to that in 1999?
Offer a very short reply. 1.22. What is the ratio of the Employment (as % of total employment) of Services in 1995 to that in 1999?
Your answer should be compact. 0.89. What is the ratio of the Employment (as % of total employment) of Self-employed in 1995 to that in 1999?
Keep it short and to the point. 0.98. What is the ratio of the Employment (as % of total employment) of Agriculture in 1995 to that in 2000?
Keep it short and to the point. 1.17. What is the ratio of the Employment (as % of total employment) in Industry in 1995 to that in 2000?
Your response must be concise. 1.19. What is the ratio of the Employment (as % of total employment) of Services in 1995 to that in 2000?
Your response must be concise. 0.89. What is the ratio of the Employment (as % of total employment) in Agriculture in 1996 to that in 1997?
Your answer should be compact. 1.04. What is the ratio of the Employment (as % of total employment) of Industry in 1996 to that in 1997?
Provide a short and direct response. 1.04. What is the ratio of the Employment (as % of total employment) in Services in 1996 to that in 1997?
Offer a very short reply. 0.97. What is the ratio of the Employment (as % of total employment) in Agriculture in 1996 to that in 1998?
Ensure brevity in your answer.  0.94. What is the ratio of the Employment (as % of total employment) in Industry in 1996 to that in 1998?
Keep it short and to the point. 1.17. What is the ratio of the Employment (as % of total employment) of Services in 1996 to that in 1998?
Offer a very short reply. 0.93. What is the ratio of the Employment (as % of total employment) in Self-employed in 1996 to that in 1998?
Give a very brief answer. 0.96. What is the ratio of the Employment (as % of total employment) in Agriculture in 1996 to that in 1999?
Your answer should be compact. 1.01. What is the ratio of the Employment (as % of total employment) in Industry in 1996 to that in 1999?
Offer a terse response. 1.19. What is the ratio of the Employment (as % of total employment) of Services in 1996 to that in 1999?
Your response must be concise. 0.92. What is the ratio of the Employment (as % of total employment) of Self-employed in 1996 to that in 1999?
Make the answer very short. 0.98. What is the ratio of the Employment (as % of total employment) of Agriculture in 1996 to that in 2000?
Keep it short and to the point. 1.1. What is the ratio of the Employment (as % of total employment) in Industry in 1996 to that in 2000?
Make the answer very short. 1.16. What is the ratio of the Employment (as % of total employment) of Services in 1996 to that in 2000?
Your response must be concise. 0.91. What is the ratio of the Employment (as % of total employment) of Agriculture in 1997 to that in 1998?
Your answer should be compact. 0.91. What is the ratio of the Employment (as % of total employment) in Industry in 1997 to that in 1998?
Make the answer very short. 1.12. What is the ratio of the Employment (as % of total employment) of Services in 1997 to that in 1998?
Give a very brief answer. 0.96. What is the ratio of the Employment (as % of total employment) of Self-employed in 1997 to that in 1998?
Your answer should be very brief. 0.96. What is the ratio of the Employment (as % of total employment) in Agriculture in 1997 to that in 1999?
Offer a very short reply. 0.97. What is the ratio of the Employment (as % of total employment) of Industry in 1997 to that in 1999?
Offer a very short reply. 1.14. What is the ratio of the Employment (as % of total employment) in Services in 1997 to that in 1999?
Make the answer very short. 0.94. What is the ratio of the Employment (as % of total employment) in Self-employed in 1997 to that in 1999?
Keep it short and to the point. 0.98. What is the ratio of the Employment (as % of total employment) in Agriculture in 1997 to that in 2000?
Give a very brief answer. 1.07. What is the ratio of the Employment (as % of total employment) in Industry in 1997 to that in 2000?
Give a very brief answer. 1.11. What is the ratio of the Employment (as % of total employment) in Services in 1997 to that in 2000?
Your response must be concise. 0.94. What is the ratio of the Employment (as % of total employment) in Agriculture in 1998 to that in 1999?
Give a very brief answer. 1.07. What is the ratio of the Employment (as % of total employment) of Industry in 1998 to that in 1999?
Offer a very short reply. 1.01. What is the ratio of the Employment (as % of total employment) in Services in 1998 to that in 1999?
Give a very brief answer. 0.98. What is the ratio of the Employment (as % of total employment) in Self-employed in 1998 to that in 1999?
Keep it short and to the point. 1.02. What is the ratio of the Employment (as % of total employment) of Agriculture in 1998 to that in 2000?
Provide a short and direct response. 1.17. What is the ratio of the Employment (as % of total employment) of Industry in 1998 to that in 2000?
Your answer should be compact. 0.99. What is the ratio of the Employment (as % of total employment) in Services in 1998 to that in 2000?
Offer a very short reply. 0.98. What is the ratio of the Employment (as % of total employment) of Self-employed in 1998 to that in 2000?
Your answer should be very brief. 1.04. What is the ratio of the Employment (as % of total employment) of Agriculture in 1999 to that in 2000?
Offer a very short reply. 1.09. What is the ratio of the Employment (as % of total employment) in Industry in 1999 to that in 2000?
Offer a terse response. 0.98. What is the ratio of the Employment (as % of total employment) in Self-employed in 1999 to that in 2000?
Make the answer very short. 1.02. What is the difference between the highest and the second highest Employment (as % of total employment) in Agriculture?
Your answer should be compact. 1.3. What is the difference between the highest and the second highest Employment (as % of total employment) of Industry?
Make the answer very short. 0.1. What is the difference between the highest and the lowest Employment (as % of total employment) of Agriculture?
Offer a terse response. 3.1. What is the difference between the highest and the lowest Employment (as % of total employment) in Services?
Make the answer very short. 8.1. What is the difference between the highest and the lowest Employment (as % of total employment) of Self-employed?
Make the answer very short. 1.6. 